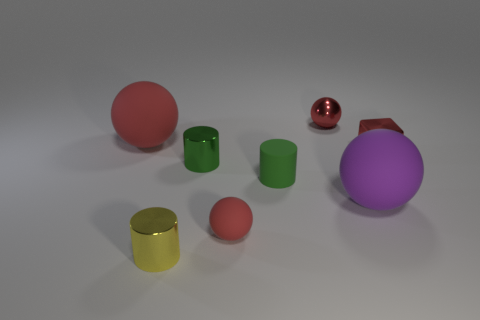Subtract all green cylinders. How many red spheres are left? 3 Subtract 1 spheres. How many spheres are left? 3 Add 2 big red things. How many objects exist? 10 Subtract all cylinders. How many objects are left? 5 Add 1 large red rubber balls. How many large red rubber balls are left? 2 Add 8 small rubber objects. How many small rubber objects exist? 10 Subtract 0 brown balls. How many objects are left? 8 Subtract all large rubber objects. Subtract all small metallic things. How many objects are left? 2 